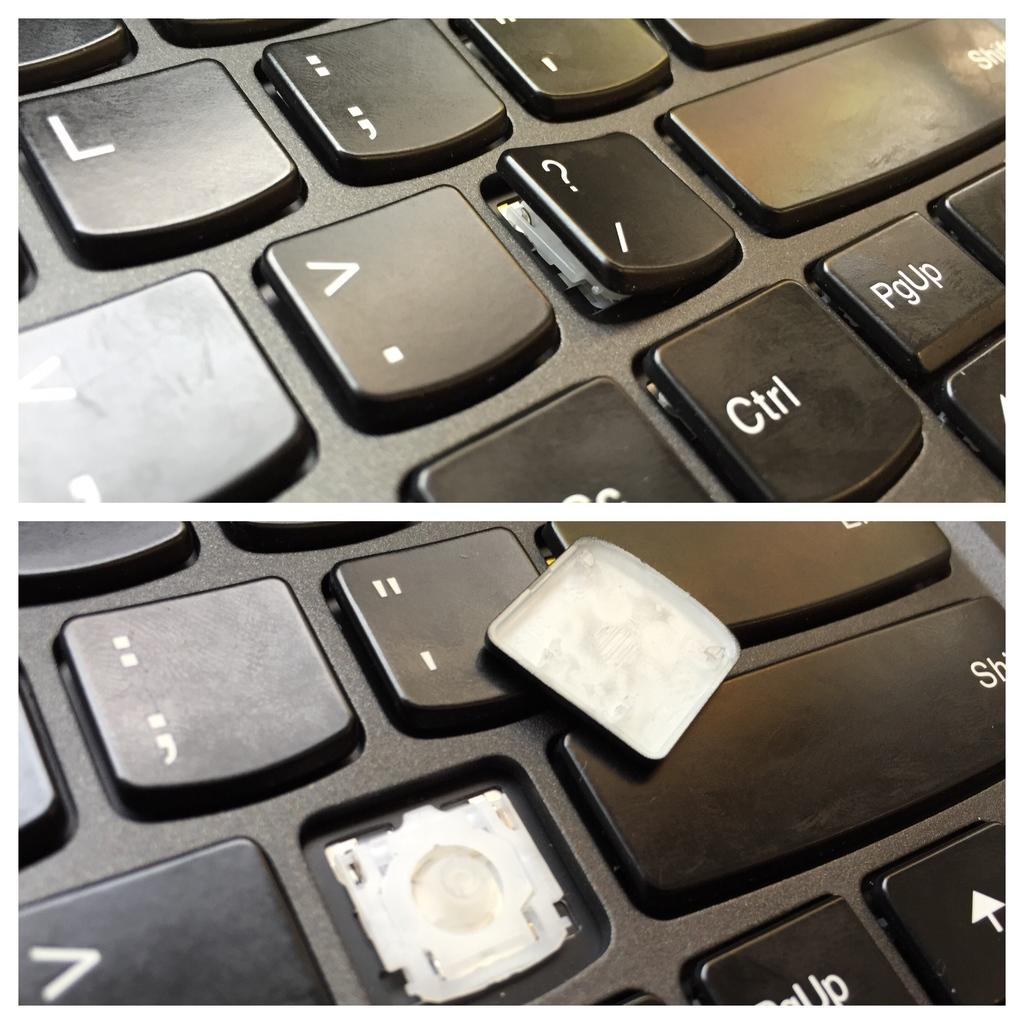<image>
Give a short and clear explanation of the subsequent image. A keyboard with various letters such as L and symbols such as ? or > displayed. 